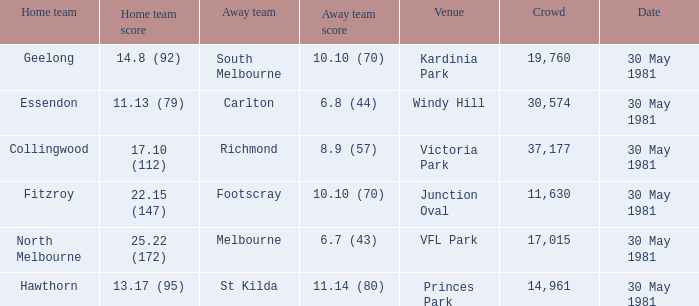What team played away at vfl park? Melbourne. 